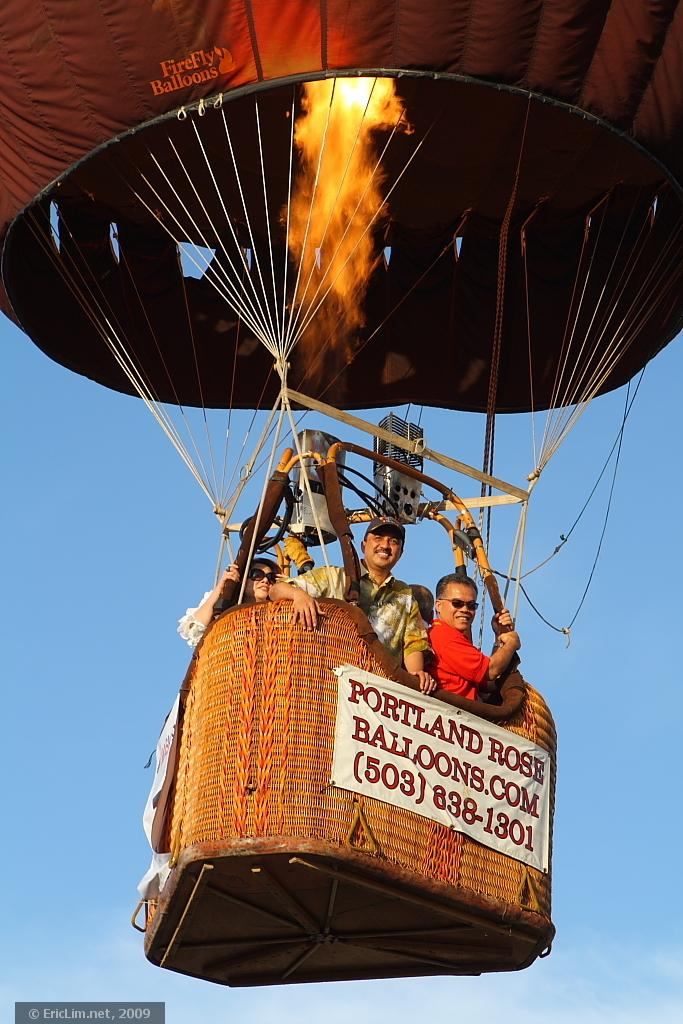<image>
Relay a brief, clear account of the picture shown. Portland Rose Balloons.com (503)-838-1301 banner on a hot balloon. 